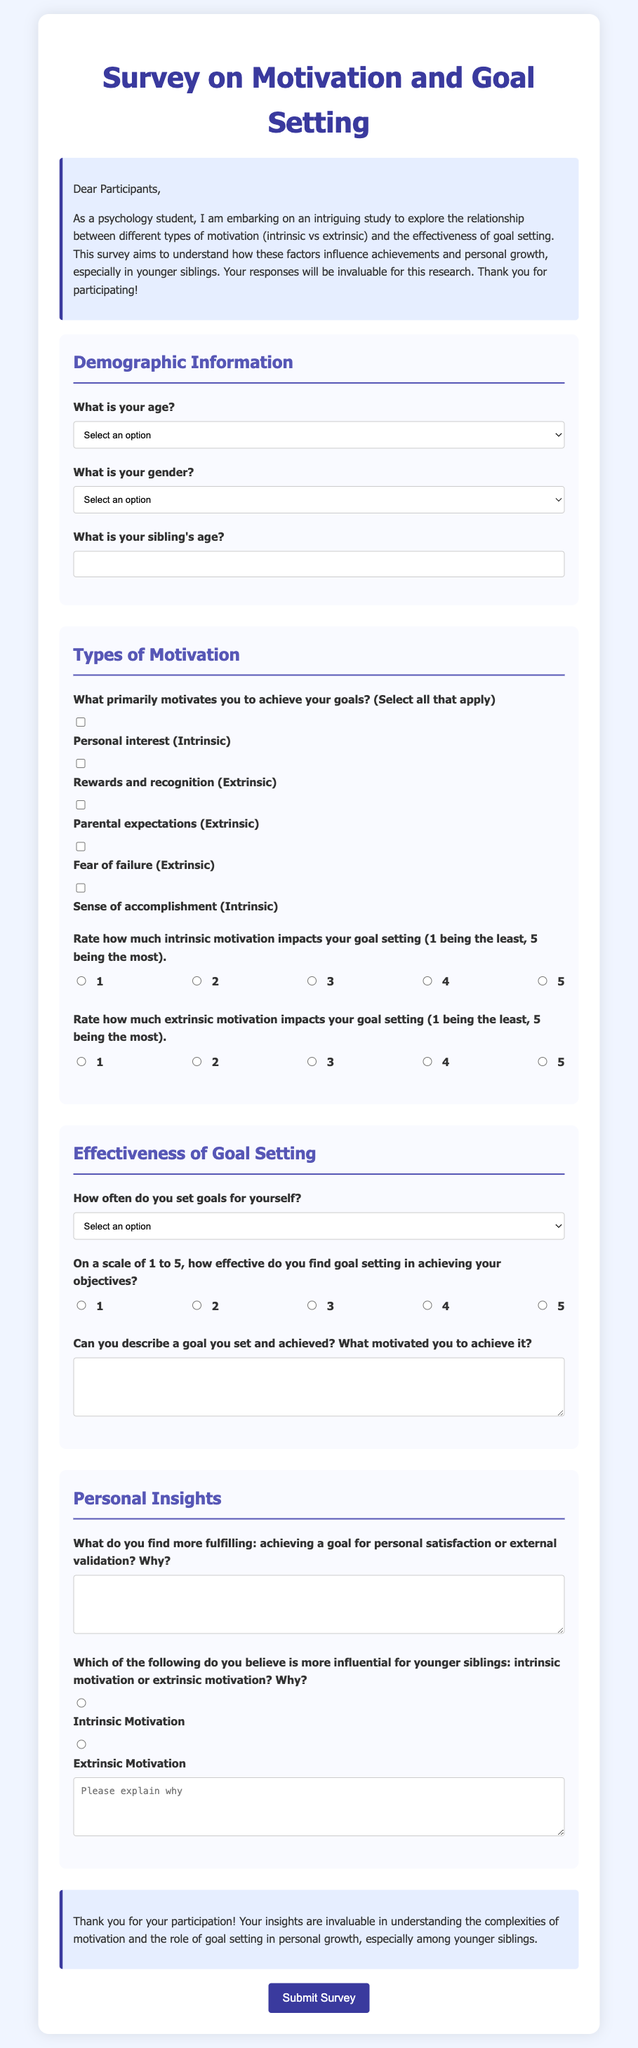What is the purpose of the survey? The purpose of the survey is to explore the relationship between different types of motivation and the effectiveness of goal setting, especially in younger siblings.
Answer: To explore the relationship between motivation and goal setting What age range is represented in the demographic section? The age range represented includes "Under 10" to "19 and above".
Answer: Under 10 to 19 and above What type of motivation does the survey categorize as "Intrinsic"? The survey categorizes "Personal interest" and "Sense of accomplishment" as intrinsic motivation.
Answer: Personal interest, Sense of accomplishment How often should participants select how frequently they set goals? Participants can select an option ranging from "Daily" to "Never".
Answer: Daily to Never On a scale from 1 to 5, what does the survey ask about goal setting effectiveness? The survey asks participants to rate how effective they find goal setting in achieving their objectives on a scale from 1 to 5.
Answer: Scale from 1 to 5 What is one of the motivating factors mentioned in the survey that is considered extrinsic? One extrinsic motivating factor mentioned is "Rewards and recognition."
Answer: Rewards and recognition Which type of motivation does the survey ask about in relation to younger siblings? The survey asks about the influence of "intrinsic motivation" and "extrinsic motivation" on younger siblings.
Answer: Intrinsic motivation, Extrinsic motivation What is the maximum number of options participants can select for their primary motivators? Participants can select multiple options, but there is no specified maximum; however, it's structured for selection among predefined motivators.
Answer: Multiple options What is the required response for the question about the sibling's age? The response must be a text entry indicating the sibling's age.
Answer: Text entry for sibling's age 